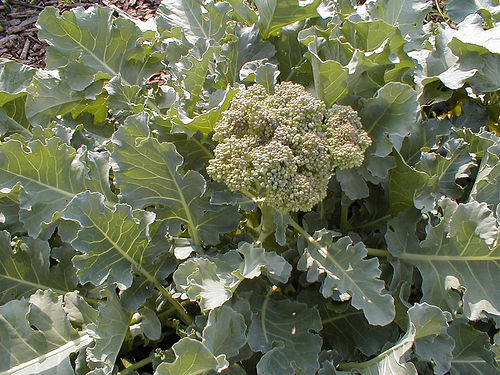How can you tell this is broccoli and not another type of plant? You can identify this as broccoli by the green florets that cluster at the head of the plant. These clusters are made up of many small flower buds that haven't yet flowered. Additionally, the broad, waxy leaves surrounding the head are typical characteristics of broccoli plants. 